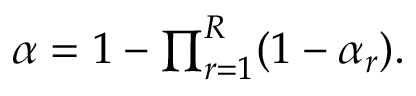Convert formula to latex. <formula><loc_0><loc_0><loc_500><loc_500>\begin{array} { r } { \alpha = 1 - \prod _ { r = 1 } ^ { R } ( 1 - \alpha _ { r } ) . } \end{array}</formula> 